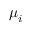<formula> <loc_0><loc_0><loc_500><loc_500>\mu _ { i }</formula> 